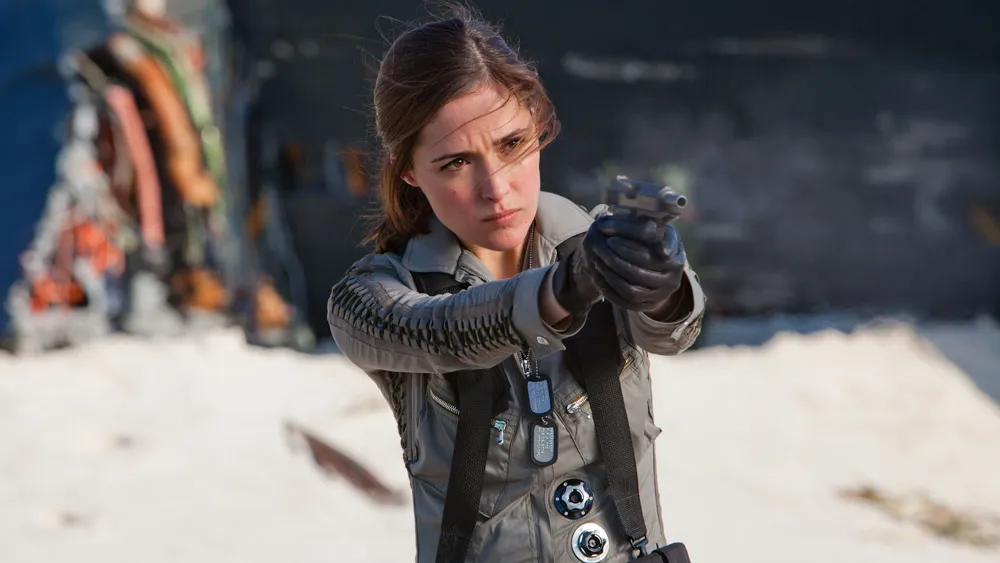Create a dialogue that could be happening in this scene. Agent Harper: (whispering into earpiece) “Command, I’ve spotted the target. Moving into position.”

Command: (through earpiece) “Proceed with caution, Harper. Remember, we need them alive.”

Agent Harper: “Copy that. Initiating approach.”

(Agent Harper slowly advances, eyes scanning the area meticulously, finger poised on the trigger. A shadow moves slightly in the distance.)

Unknown Voice: (from the shadows) “You don’t have to do this, Harper.”

Agent Harper: (steady, focused) “Show yourself. We can end this peacefully.”

(The figure steps out, hands raised but eyes narrowed in defiance.) What might be happening in the background that's not directly visible? In the background, beyond what is immediately visible, there might be a larger tactical operation underway. Additional team members could be stealthily moving into strategic positions, ready to support Agent Harper if needed. There could be surveillance drones hovering silently, providing real-time data to command. The setting might also hint at a broader conflict, with remnants of past battles and hints of ongoing struggle in the distance. The unseen environment is likely charged with tension, every element contributing to the high-stakes scenario unfolding before the camera. 